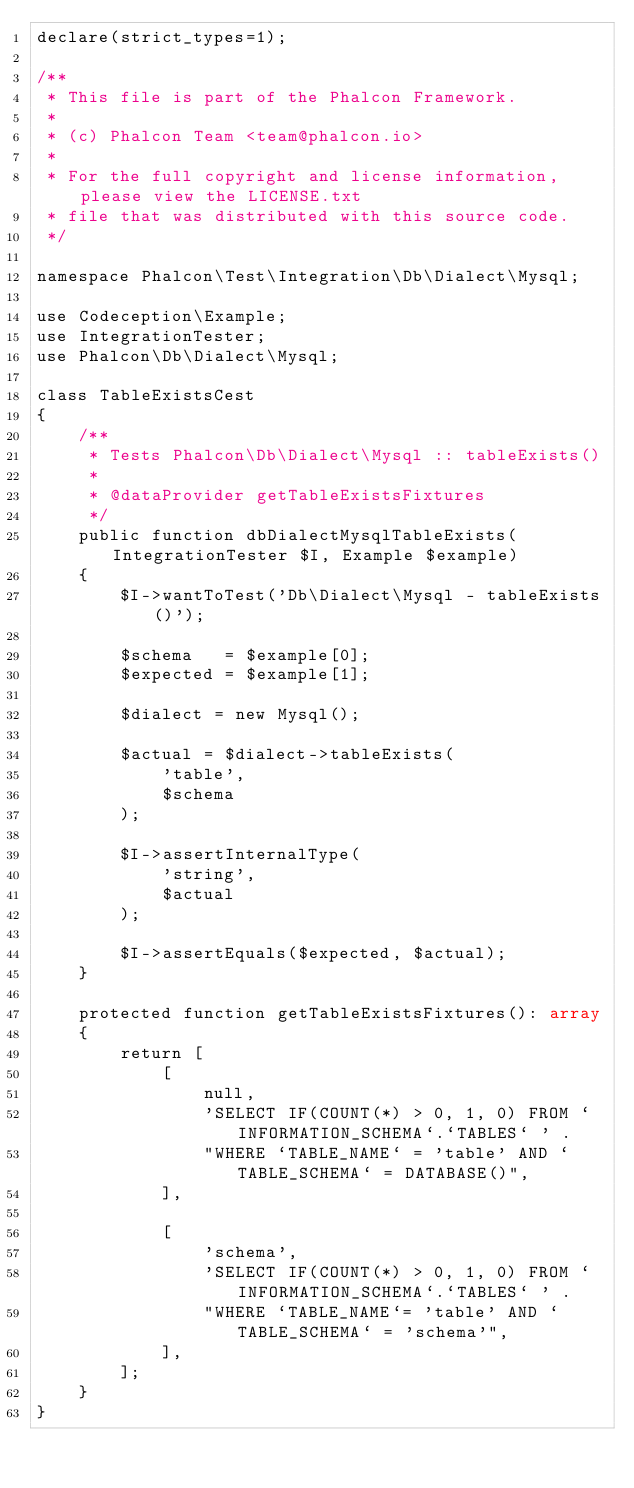Convert code to text. <code><loc_0><loc_0><loc_500><loc_500><_PHP_>declare(strict_types=1);

/**
 * This file is part of the Phalcon Framework.
 *
 * (c) Phalcon Team <team@phalcon.io>
 *
 * For the full copyright and license information, please view the LICENSE.txt
 * file that was distributed with this source code.
 */

namespace Phalcon\Test\Integration\Db\Dialect\Mysql;

use Codeception\Example;
use IntegrationTester;
use Phalcon\Db\Dialect\Mysql;

class TableExistsCest
{
    /**
     * Tests Phalcon\Db\Dialect\Mysql :: tableExists()
     *
     * @dataProvider getTableExistsFixtures
     */
    public function dbDialectMysqlTableExists(IntegrationTester $I, Example $example)
    {
        $I->wantToTest('Db\Dialect\Mysql - tableExists()');

        $schema   = $example[0];
        $expected = $example[1];

        $dialect = new Mysql();

        $actual = $dialect->tableExists(
            'table',
            $schema
        );

        $I->assertInternalType(
            'string',
            $actual
        );

        $I->assertEquals($expected, $actual);
    }

    protected function getTableExistsFixtures(): array
    {
        return [
            [
                null,
                'SELECT IF(COUNT(*) > 0, 1, 0) FROM `INFORMATION_SCHEMA`.`TABLES` ' .
                "WHERE `TABLE_NAME` = 'table' AND `TABLE_SCHEMA` = DATABASE()",
            ],

            [
                'schema',
                'SELECT IF(COUNT(*) > 0, 1, 0) FROM `INFORMATION_SCHEMA`.`TABLES` ' .
                "WHERE `TABLE_NAME`= 'table' AND `TABLE_SCHEMA` = 'schema'",
            ],
        ];
    }
}
</code> 